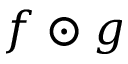Convert formula to latex. <formula><loc_0><loc_0><loc_500><loc_500>f \odot g</formula> 